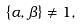<formula> <loc_0><loc_0><loc_500><loc_500>\{ \alpha , \beta \} \neq 1 ,</formula> 